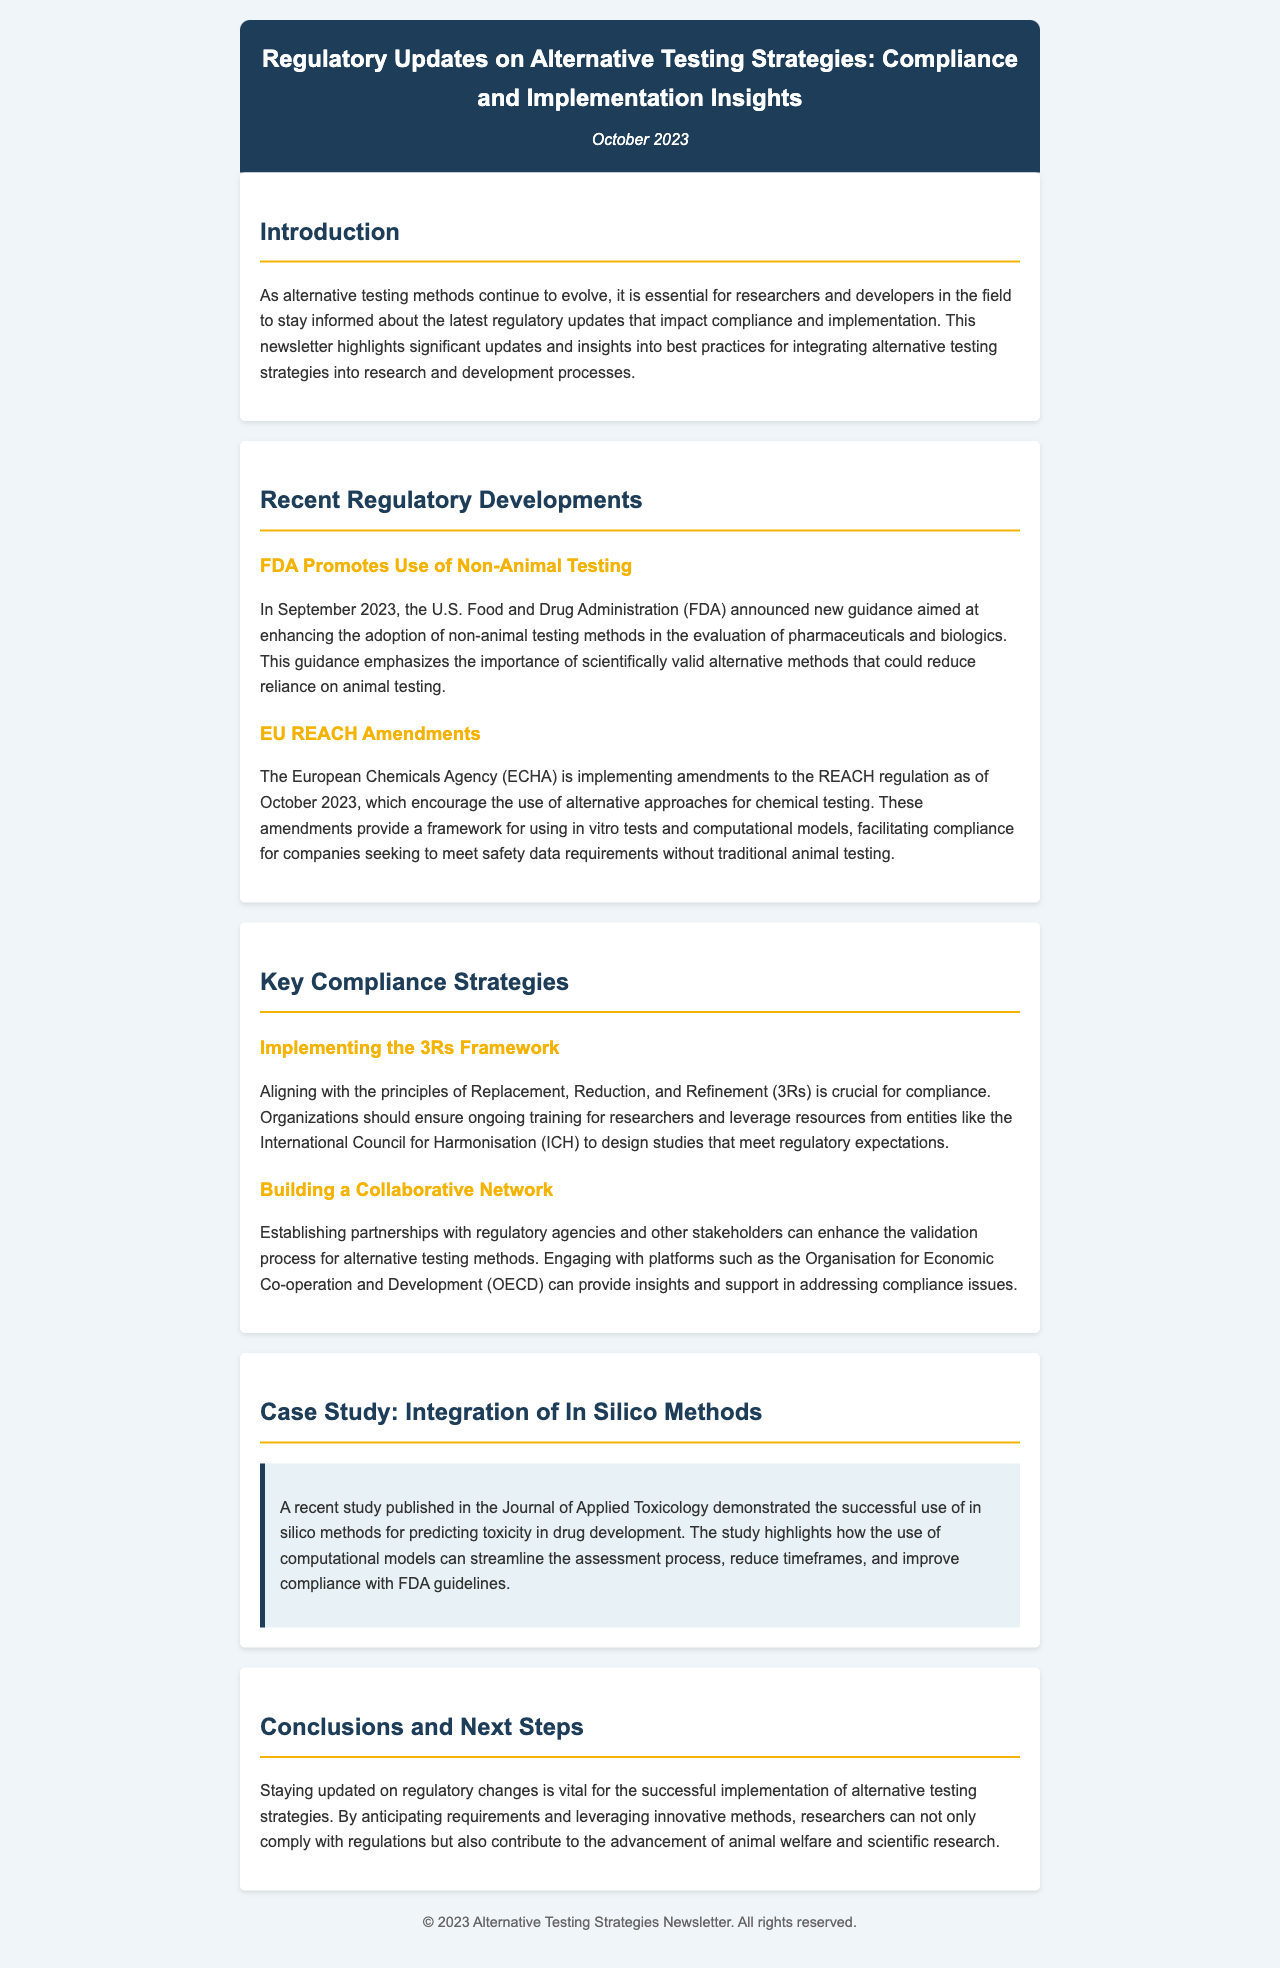What is the title of the newsletter? The title is the main heading of the newsletter, which summarizes its focus on alternative testing strategies.
Answer: Regulatory Updates on Alternative Testing Strategies: Compliance and Implementation Insights When was this newsletter published? The publication date is usually stated in a specific format within the newsletter, indicating its release.
Answer: October 2023 Which agency promotes the use of non-animal testing? The agency responsible for enhancing the adoption of non-animal testing methods is mentioned in the recent regulatory developments.
Answer: FDA What framework should organizations implement for compliance? The framework is referred to in the compliance strategies section and is essential for ethical testing practices.
Answer: 3Rs Framework Which organization can provide support in addressing compliance issues? The organization mentioned that assists with compliance issues in alternative testing methods is identified in the document.
Answer: OECD What is the focus of the case study highlighted in the newsletter? The case study discusses a specific method utilized in drug development to demonstrate a successful application of regulatory compliance.
Answer: Integration of In Silico Methods What is the main goal of staying updated on regulatory changes? The goal is stated in the conclusions, emphasizing the importance for researchers in the context of alternative testing strategies.
Answer: Successful implementation What is a recent regulatory amendment mentioned? The amendment relates to an existing regulation and is significant for companies meeting safety data requirements without traditional testing methods.
Answer: EU REACH Amendments What approach does the FDA guidance emphasize? The specific approach is stated to encourage the adoption of ethical testing methods in the pharmaceutical industry.
Answer: Non-animal testing methods 